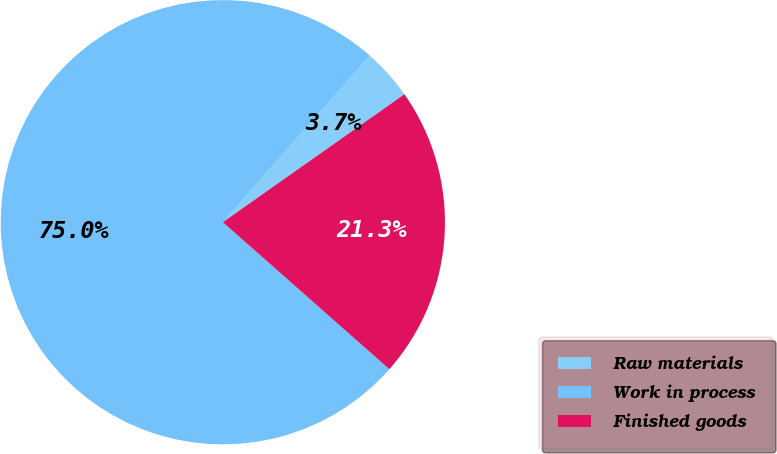<chart> <loc_0><loc_0><loc_500><loc_500><pie_chart><fcel>Raw materials<fcel>Work in process<fcel>Finished goods<nl><fcel>3.72%<fcel>75.0%<fcel>21.28%<nl></chart> 